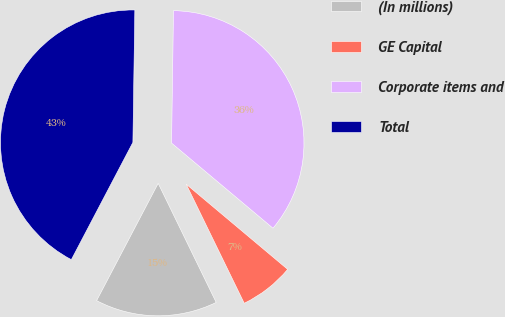Convert chart. <chart><loc_0><loc_0><loc_500><loc_500><pie_chart><fcel>(In millions)<fcel>GE Capital<fcel>Corporate items and<fcel>Total<nl><fcel>14.91%<fcel>6.67%<fcel>35.88%<fcel>42.54%<nl></chart> 